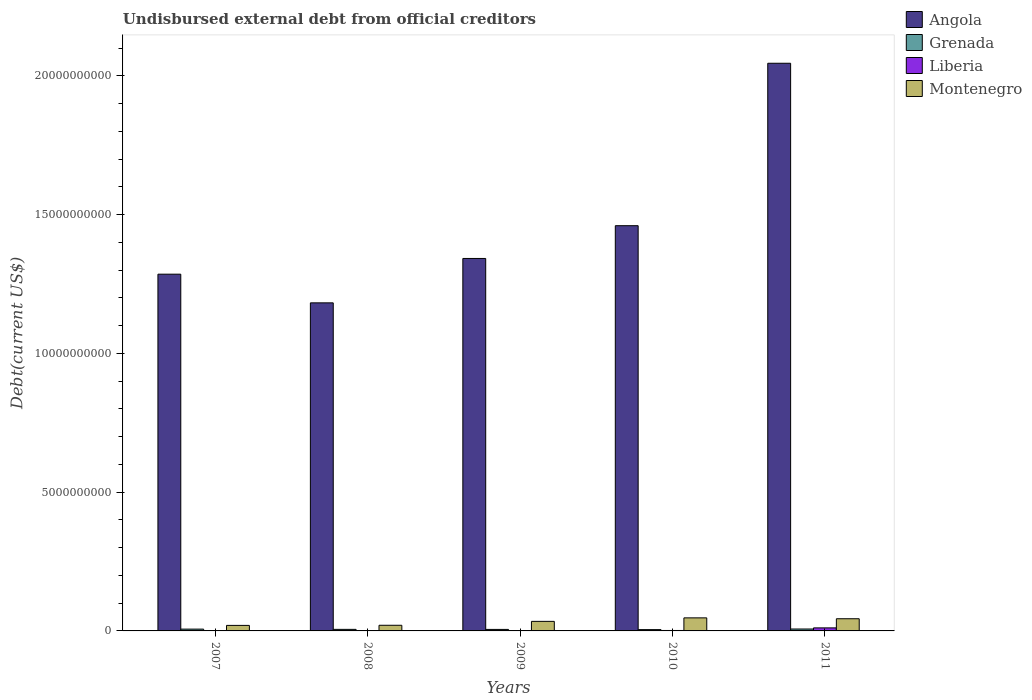How many groups of bars are there?
Make the answer very short. 5. Are the number of bars per tick equal to the number of legend labels?
Provide a succinct answer. Yes. Are the number of bars on each tick of the X-axis equal?
Keep it short and to the point. Yes. What is the label of the 2nd group of bars from the left?
Provide a short and direct response. 2008. In how many cases, is the number of bars for a given year not equal to the number of legend labels?
Give a very brief answer. 0. What is the total debt in Grenada in 2009?
Make the answer very short. 5.44e+07. Across all years, what is the maximum total debt in Angola?
Provide a succinct answer. 2.05e+1. Across all years, what is the minimum total debt in Angola?
Provide a succinct answer. 1.18e+1. In which year was the total debt in Montenegro minimum?
Your answer should be very brief. 2007. What is the total total debt in Angola in the graph?
Give a very brief answer. 7.32e+1. What is the difference between the total debt in Angola in 2007 and that in 2010?
Offer a terse response. -1.75e+09. What is the difference between the total debt in Liberia in 2011 and the total debt in Montenegro in 2008?
Offer a terse response. -9.45e+07. What is the average total debt in Montenegro per year?
Make the answer very short. 3.31e+08. In the year 2011, what is the difference between the total debt in Angola and total debt in Grenada?
Give a very brief answer. 2.04e+1. In how many years, is the total debt in Grenada greater than 2000000000 US$?
Your answer should be compact. 0. What is the ratio of the total debt in Liberia in 2010 to that in 2011?
Offer a terse response. 0.15. Is the total debt in Angola in 2007 less than that in 2010?
Give a very brief answer. Yes. Is the difference between the total debt in Angola in 2009 and 2010 greater than the difference between the total debt in Grenada in 2009 and 2010?
Keep it short and to the point. No. What is the difference between the highest and the second highest total debt in Montenegro?
Your answer should be compact. 3.17e+07. What is the difference between the highest and the lowest total debt in Grenada?
Keep it short and to the point. 2.21e+07. Is the sum of the total debt in Angola in 2007 and 2011 greater than the maximum total debt in Grenada across all years?
Offer a very short reply. Yes. What does the 2nd bar from the left in 2009 represents?
Your response must be concise. Grenada. What does the 2nd bar from the right in 2010 represents?
Give a very brief answer. Liberia. Is it the case that in every year, the sum of the total debt in Liberia and total debt in Montenegro is greater than the total debt in Angola?
Keep it short and to the point. No. Are all the bars in the graph horizontal?
Provide a short and direct response. No. How many years are there in the graph?
Provide a short and direct response. 5. What is the difference between two consecutive major ticks on the Y-axis?
Your answer should be compact. 5.00e+09. Does the graph contain any zero values?
Offer a terse response. No. Does the graph contain grids?
Ensure brevity in your answer.  No. Where does the legend appear in the graph?
Provide a succinct answer. Top right. What is the title of the graph?
Your response must be concise. Undisbursed external debt from official creditors. Does "Turks and Caicos Islands" appear as one of the legend labels in the graph?
Offer a very short reply. No. What is the label or title of the X-axis?
Your answer should be compact. Years. What is the label or title of the Y-axis?
Your answer should be compact. Debt(current US$). What is the Debt(current US$) of Angola in 2007?
Keep it short and to the point. 1.29e+1. What is the Debt(current US$) in Grenada in 2007?
Your response must be concise. 6.52e+07. What is the Debt(current US$) in Liberia in 2007?
Provide a short and direct response. 5.48e+06. What is the Debt(current US$) in Montenegro in 2007?
Offer a very short reply. 1.99e+08. What is the Debt(current US$) of Angola in 2008?
Your answer should be compact. 1.18e+1. What is the Debt(current US$) of Grenada in 2008?
Provide a succinct answer. 5.57e+07. What is the Debt(current US$) of Liberia in 2008?
Your answer should be compact. 5.85e+06. What is the Debt(current US$) in Montenegro in 2008?
Keep it short and to the point. 2.04e+08. What is the Debt(current US$) of Angola in 2009?
Provide a short and direct response. 1.34e+1. What is the Debt(current US$) in Grenada in 2009?
Offer a terse response. 5.44e+07. What is the Debt(current US$) of Liberia in 2009?
Provide a succinct answer. 5.86e+06. What is the Debt(current US$) of Montenegro in 2009?
Offer a very short reply. 3.44e+08. What is the Debt(current US$) of Angola in 2010?
Provide a succinct answer. 1.46e+1. What is the Debt(current US$) in Grenada in 2010?
Make the answer very short. 4.69e+07. What is the Debt(current US$) of Liberia in 2010?
Give a very brief answer. 1.60e+07. What is the Debt(current US$) of Montenegro in 2010?
Keep it short and to the point. 4.71e+08. What is the Debt(current US$) of Angola in 2011?
Keep it short and to the point. 2.05e+1. What is the Debt(current US$) of Grenada in 2011?
Your answer should be very brief. 6.91e+07. What is the Debt(current US$) in Liberia in 2011?
Provide a short and direct response. 1.09e+08. What is the Debt(current US$) in Montenegro in 2011?
Give a very brief answer. 4.39e+08. Across all years, what is the maximum Debt(current US$) in Angola?
Offer a terse response. 2.05e+1. Across all years, what is the maximum Debt(current US$) of Grenada?
Offer a terse response. 6.91e+07. Across all years, what is the maximum Debt(current US$) in Liberia?
Give a very brief answer. 1.09e+08. Across all years, what is the maximum Debt(current US$) of Montenegro?
Your response must be concise. 4.71e+08. Across all years, what is the minimum Debt(current US$) of Angola?
Your response must be concise. 1.18e+1. Across all years, what is the minimum Debt(current US$) in Grenada?
Your answer should be compact. 4.69e+07. Across all years, what is the minimum Debt(current US$) in Liberia?
Keep it short and to the point. 5.48e+06. Across all years, what is the minimum Debt(current US$) in Montenegro?
Provide a succinct answer. 1.99e+08. What is the total Debt(current US$) in Angola in the graph?
Your answer should be compact. 7.32e+1. What is the total Debt(current US$) in Grenada in the graph?
Keep it short and to the point. 2.91e+08. What is the total Debt(current US$) in Liberia in the graph?
Keep it short and to the point. 1.42e+08. What is the total Debt(current US$) of Montenegro in the graph?
Give a very brief answer. 1.66e+09. What is the difference between the Debt(current US$) in Angola in 2007 and that in 2008?
Your answer should be very brief. 1.03e+09. What is the difference between the Debt(current US$) in Grenada in 2007 and that in 2008?
Your response must be concise. 9.50e+06. What is the difference between the Debt(current US$) of Liberia in 2007 and that in 2008?
Provide a succinct answer. -3.77e+05. What is the difference between the Debt(current US$) of Montenegro in 2007 and that in 2008?
Offer a very short reply. -4.64e+06. What is the difference between the Debt(current US$) of Angola in 2007 and that in 2009?
Provide a succinct answer. -5.66e+08. What is the difference between the Debt(current US$) in Grenada in 2007 and that in 2009?
Make the answer very short. 1.08e+07. What is the difference between the Debt(current US$) of Liberia in 2007 and that in 2009?
Offer a very short reply. -3.82e+05. What is the difference between the Debt(current US$) of Montenegro in 2007 and that in 2009?
Ensure brevity in your answer.  -1.45e+08. What is the difference between the Debt(current US$) of Angola in 2007 and that in 2010?
Your answer should be very brief. -1.75e+09. What is the difference between the Debt(current US$) in Grenada in 2007 and that in 2010?
Ensure brevity in your answer.  1.83e+07. What is the difference between the Debt(current US$) of Liberia in 2007 and that in 2010?
Make the answer very short. -1.06e+07. What is the difference between the Debt(current US$) of Montenegro in 2007 and that in 2010?
Offer a very short reply. -2.72e+08. What is the difference between the Debt(current US$) of Angola in 2007 and that in 2011?
Provide a short and direct response. -7.60e+09. What is the difference between the Debt(current US$) in Grenada in 2007 and that in 2011?
Provide a short and direct response. -3.84e+06. What is the difference between the Debt(current US$) of Liberia in 2007 and that in 2011?
Keep it short and to the point. -1.04e+08. What is the difference between the Debt(current US$) in Montenegro in 2007 and that in 2011?
Offer a very short reply. -2.40e+08. What is the difference between the Debt(current US$) in Angola in 2008 and that in 2009?
Provide a succinct answer. -1.60e+09. What is the difference between the Debt(current US$) of Grenada in 2008 and that in 2009?
Your response must be concise. 1.34e+06. What is the difference between the Debt(current US$) of Liberia in 2008 and that in 2009?
Make the answer very short. -5000. What is the difference between the Debt(current US$) of Montenegro in 2008 and that in 2009?
Offer a very short reply. -1.40e+08. What is the difference between the Debt(current US$) of Angola in 2008 and that in 2010?
Provide a succinct answer. -2.78e+09. What is the difference between the Debt(current US$) in Grenada in 2008 and that in 2010?
Offer a very short reply. 8.79e+06. What is the difference between the Debt(current US$) in Liberia in 2008 and that in 2010?
Keep it short and to the point. -1.02e+07. What is the difference between the Debt(current US$) in Montenegro in 2008 and that in 2010?
Provide a succinct answer. -2.67e+08. What is the difference between the Debt(current US$) in Angola in 2008 and that in 2011?
Give a very brief answer. -8.63e+09. What is the difference between the Debt(current US$) in Grenada in 2008 and that in 2011?
Ensure brevity in your answer.  -1.33e+07. What is the difference between the Debt(current US$) in Liberia in 2008 and that in 2011?
Ensure brevity in your answer.  -1.03e+08. What is the difference between the Debt(current US$) in Montenegro in 2008 and that in 2011?
Make the answer very short. -2.35e+08. What is the difference between the Debt(current US$) of Angola in 2009 and that in 2010?
Give a very brief answer. -1.18e+09. What is the difference between the Debt(current US$) of Grenada in 2009 and that in 2010?
Ensure brevity in your answer.  7.44e+06. What is the difference between the Debt(current US$) in Liberia in 2009 and that in 2010?
Your answer should be very brief. -1.02e+07. What is the difference between the Debt(current US$) in Montenegro in 2009 and that in 2010?
Keep it short and to the point. -1.27e+08. What is the difference between the Debt(current US$) in Angola in 2009 and that in 2011?
Your answer should be compact. -7.03e+09. What is the difference between the Debt(current US$) in Grenada in 2009 and that in 2011?
Ensure brevity in your answer.  -1.47e+07. What is the difference between the Debt(current US$) of Liberia in 2009 and that in 2011?
Make the answer very short. -1.03e+08. What is the difference between the Debt(current US$) of Montenegro in 2009 and that in 2011?
Provide a succinct answer. -9.49e+07. What is the difference between the Debt(current US$) in Angola in 2010 and that in 2011?
Make the answer very short. -5.85e+09. What is the difference between the Debt(current US$) in Grenada in 2010 and that in 2011?
Your response must be concise. -2.21e+07. What is the difference between the Debt(current US$) of Liberia in 2010 and that in 2011?
Make the answer very short. -9.32e+07. What is the difference between the Debt(current US$) in Montenegro in 2010 and that in 2011?
Keep it short and to the point. 3.17e+07. What is the difference between the Debt(current US$) of Angola in 2007 and the Debt(current US$) of Grenada in 2008?
Your answer should be very brief. 1.28e+1. What is the difference between the Debt(current US$) in Angola in 2007 and the Debt(current US$) in Liberia in 2008?
Offer a very short reply. 1.29e+1. What is the difference between the Debt(current US$) of Angola in 2007 and the Debt(current US$) of Montenegro in 2008?
Provide a short and direct response. 1.27e+1. What is the difference between the Debt(current US$) of Grenada in 2007 and the Debt(current US$) of Liberia in 2008?
Offer a terse response. 5.94e+07. What is the difference between the Debt(current US$) of Grenada in 2007 and the Debt(current US$) of Montenegro in 2008?
Your answer should be very brief. -1.38e+08. What is the difference between the Debt(current US$) in Liberia in 2007 and the Debt(current US$) in Montenegro in 2008?
Make the answer very short. -1.98e+08. What is the difference between the Debt(current US$) of Angola in 2007 and the Debt(current US$) of Grenada in 2009?
Make the answer very short. 1.28e+1. What is the difference between the Debt(current US$) in Angola in 2007 and the Debt(current US$) in Liberia in 2009?
Provide a short and direct response. 1.29e+1. What is the difference between the Debt(current US$) of Angola in 2007 and the Debt(current US$) of Montenegro in 2009?
Give a very brief answer. 1.25e+1. What is the difference between the Debt(current US$) of Grenada in 2007 and the Debt(current US$) of Liberia in 2009?
Offer a very short reply. 5.94e+07. What is the difference between the Debt(current US$) of Grenada in 2007 and the Debt(current US$) of Montenegro in 2009?
Your answer should be compact. -2.79e+08. What is the difference between the Debt(current US$) of Liberia in 2007 and the Debt(current US$) of Montenegro in 2009?
Offer a very short reply. -3.39e+08. What is the difference between the Debt(current US$) of Angola in 2007 and the Debt(current US$) of Grenada in 2010?
Offer a very short reply. 1.28e+1. What is the difference between the Debt(current US$) in Angola in 2007 and the Debt(current US$) in Liberia in 2010?
Ensure brevity in your answer.  1.28e+1. What is the difference between the Debt(current US$) in Angola in 2007 and the Debt(current US$) in Montenegro in 2010?
Give a very brief answer. 1.24e+1. What is the difference between the Debt(current US$) of Grenada in 2007 and the Debt(current US$) of Liberia in 2010?
Your response must be concise. 4.92e+07. What is the difference between the Debt(current US$) of Grenada in 2007 and the Debt(current US$) of Montenegro in 2010?
Give a very brief answer. -4.05e+08. What is the difference between the Debt(current US$) in Liberia in 2007 and the Debt(current US$) in Montenegro in 2010?
Offer a very short reply. -4.65e+08. What is the difference between the Debt(current US$) in Angola in 2007 and the Debt(current US$) in Grenada in 2011?
Offer a very short reply. 1.28e+1. What is the difference between the Debt(current US$) of Angola in 2007 and the Debt(current US$) of Liberia in 2011?
Ensure brevity in your answer.  1.27e+1. What is the difference between the Debt(current US$) in Angola in 2007 and the Debt(current US$) in Montenegro in 2011?
Your answer should be compact. 1.24e+1. What is the difference between the Debt(current US$) of Grenada in 2007 and the Debt(current US$) of Liberia in 2011?
Offer a terse response. -4.40e+07. What is the difference between the Debt(current US$) of Grenada in 2007 and the Debt(current US$) of Montenegro in 2011?
Make the answer very short. -3.74e+08. What is the difference between the Debt(current US$) of Liberia in 2007 and the Debt(current US$) of Montenegro in 2011?
Give a very brief answer. -4.33e+08. What is the difference between the Debt(current US$) of Angola in 2008 and the Debt(current US$) of Grenada in 2009?
Make the answer very short. 1.18e+1. What is the difference between the Debt(current US$) of Angola in 2008 and the Debt(current US$) of Liberia in 2009?
Offer a terse response. 1.18e+1. What is the difference between the Debt(current US$) in Angola in 2008 and the Debt(current US$) in Montenegro in 2009?
Offer a terse response. 1.15e+1. What is the difference between the Debt(current US$) of Grenada in 2008 and the Debt(current US$) of Liberia in 2009?
Your answer should be very brief. 4.99e+07. What is the difference between the Debt(current US$) of Grenada in 2008 and the Debt(current US$) of Montenegro in 2009?
Your answer should be compact. -2.88e+08. What is the difference between the Debt(current US$) of Liberia in 2008 and the Debt(current US$) of Montenegro in 2009?
Offer a terse response. -3.38e+08. What is the difference between the Debt(current US$) of Angola in 2008 and the Debt(current US$) of Grenada in 2010?
Ensure brevity in your answer.  1.18e+1. What is the difference between the Debt(current US$) in Angola in 2008 and the Debt(current US$) in Liberia in 2010?
Keep it short and to the point. 1.18e+1. What is the difference between the Debt(current US$) of Angola in 2008 and the Debt(current US$) of Montenegro in 2010?
Your answer should be very brief. 1.14e+1. What is the difference between the Debt(current US$) of Grenada in 2008 and the Debt(current US$) of Liberia in 2010?
Give a very brief answer. 3.97e+07. What is the difference between the Debt(current US$) in Grenada in 2008 and the Debt(current US$) in Montenegro in 2010?
Provide a short and direct response. -4.15e+08. What is the difference between the Debt(current US$) of Liberia in 2008 and the Debt(current US$) of Montenegro in 2010?
Provide a succinct answer. -4.65e+08. What is the difference between the Debt(current US$) in Angola in 2008 and the Debt(current US$) in Grenada in 2011?
Ensure brevity in your answer.  1.18e+1. What is the difference between the Debt(current US$) in Angola in 2008 and the Debt(current US$) in Liberia in 2011?
Your answer should be compact. 1.17e+1. What is the difference between the Debt(current US$) of Angola in 2008 and the Debt(current US$) of Montenegro in 2011?
Give a very brief answer. 1.14e+1. What is the difference between the Debt(current US$) in Grenada in 2008 and the Debt(current US$) in Liberia in 2011?
Provide a succinct answer. -5.35e+07. What is the difference between the Debt(current US$) in Grenada in 2008 and the Debt(current US$) in Montenegro in 2011?
Your answer should be very brief. -3.83e+08. What is the difference between the Debt(current US$) in Liberia in 2008 and the Debt(current US$) in Montenegro in 2011?
Offer a very short reply. -4.33e+08. What is the difference between the Debt(current US$) of Angola in 2009 and the Debt(current US$) of Grenada in 2010?
Offer a terse response. 1.34e+1. What is the difference between the Debt(current US$) in Angola in 2009 and the Debt(current US$) in Liberia in 2010?
Provide a short and direct response. 1.34e+1. What is the difference between the Debt(current US$) in Angola in 2009 and the Debt(current US$) in Montenegro in 2010?
Your answer should be very brief. 1.30e+1. What is the difference between the Debt(current US$) of Grenada in 2009 and the Debt(current US$) of Liberia in 2010?
Your answer should be very brief. 3.83e+07. What is the difference between the Debt(current US$) in Grenada in 2009 and the Debt(current US$) in Montenegro in 2010?
Offer a very short reply. -4.16e+08. What is the difference between the Debt(current US$) of Liberia in 2009 and the Debt(current US$) of Montenegro in 2010?
Provide a short and direct response. -4.65e+08. What is the difference between the Debt(current US$) of Angola in 2009 and the Debt(current US$) of Grenada in 2011?
Offer a very short reply. 1.34e+1. What is the difference between the Debt(current US$) in Angola in 2009 and the Debt(current US$) in Liberia in 2011?
Make the answer very short. 1.33e+1. What is the difference between the Debt(current US$) of Angola in 2009 and the Debt(current US$) of Montenegro in 2011?
Keep it short and to the point. 1.30e+1. What is the difference between the Debt(current US$) of Grenada in 2009 and the Debt(current US$) of Liberia in 2011?
Make the answer very short. -5.49e+07. What is the difference between the Debt(current US$) in Grenada in 2009 and the Debt(current US$) in Montenegro in 2011?
Your answer should be compact. -3.85e+08. What is the difference between the Debt(current US$) of Liberia in 2009 and the Debt(current US$) of Montenegro in 2011?
Keep it short and to the point. -4.33e+08. What is the difference between the Debt(current US$) in Angola in 2010 and the Debt(current US$) in Grenada in 2011?
Your answer should be compact. 1.45e+1. What is the difference between the Debt(current US$) of Angola in 2010 and the Debt(current US$) of Liberia in 2011?
Offer a very short reply. 1.45e+1. What is the difference between the Debt(current US$) of Angola in 2010 and the Debt(current US$) of Montenegro in 2011?
Keep it short and to the point. 1.42e+1. What is the difference between the Debt(current US$) of Grenada in 2010 and the Debt(current US$) of Liberia in 2011?
Give a very brief answer. -6.23e+07. What is the difference between the Debt(current US$) in Grenada in 2010 and the Debt(current US$) in Montenegro in 2011?
Your response must be concise. -3.92e+08. What is the difference between the Debt(current US$) in Liberia in 2010 and the Debt(current US$) in Montenegro in 2011?
Offer a very short reply. -4.23e+08. What is the average Debt(current US$) of Angola per year?
Offer a very short reply. 1.46e+1. What is the average Debt(current US$) of Grenada per year?
Provide a short and direct response. 5.83e+07. What is the average Debt(current US$) of Liberia per year?
Your answer should be very brief. 2.85e+07. What is the average Debt(current US$) of Montenegro per year?
Provide a succinct answer. 3.31e+08. In the year 2007, what is the difference between the Debt(current US$) in Angola and Debt(current US$) in Grenada?
Make the answer very short. 1.28e+1. In the year 2007, what is the difference between the Debt(current US$) of Angola and Debt(current US$) of Liberia?
Give a very brief answer. 1.29e+1. In the year 2007, what is the difference between the Debt(current US$) of Angola and Debt(current US$) of Montenegro?
Provide a short and direct response. 1.27e+1. In the year 2007, what is the difference between the Debt(current US$) in Grenada and Debt(current US$) in Liberia?
Provide a succinct answer. 5.98e+07. In the year 2007, what is the difference between the Debt(current US$) in Grenada and Debt(current US$) in Montenegro?
Your answer should be very brief. -1.34e+08. In the year 2007, what is the difference between the Debt(current US$) of Liberia and Debt(current US$) of Montenegro?
Provide a short and direct response. -1.94e+08. In the year 2008, what is the difference between the Debt(current US$) of Angola and Debt(current US$) of Grenada?
Provide a short and direct response. 1.18e+1. In the year 2008, what is the difference between the Debt(current US$) in Angola and Debt(current US$) in Liberia?
Provide a succinct answer. 1.18e+1. In the year 2008, what is the difference between the Debt(current US$) in Angola and Debt(current US$) in Montenegro?
Offer a very short reply. 1.16e+1. In the year 2008, what is the difference between the Debt(current US$) of Grenada and Debt(current US$) of Liberia?
Give a very brief answer. 4.99e+07. In the year 2008, what is the difference between the Debt(current US$) of Grenada and Debt(current US$) of Montenegro?
Give a very brief answer. -1.48e+08. In the year 2008, what is the difference between the Debt(current US$) in Liberia and Debt(current US$) in Montenegro?
Offer a very short reply. -1.98e+08. In the year 2009, what is the difference between the Debt(current US$) in Angola and Debt(current US$) in Grenada?
Offer a very short reply. 1.34e+1. In the year 2009, what is the difference between the Debt(current US$) in Angola and Debt(current US$) in Liberia?
Your answer should be very brief. 1.34e+1. In the year 2009, what is the difference between the Debt(current US$) in Angola and Debt(current US$) in Montenegro?
Provide a short and direct response. 1.31e+1. In the year 2009, what is the difference between the Debt(current US$) in Grenada and Debt(current US$) in Liberia?
Your response must be concise. 4.85e+07. In the year 2009, what is the difference between the Debt(current US$) of Grenada and Debt(current US$) of Montenegro?
Make the answer very short. -2.90e+08. In the year 2009, what is the difference between the Debt(current US$) in Liberia and Debt(current US$) in Montenegro?
Make the answer very short. -3.38e+08. In the year 2010, what is the difference between the Debt(current US$) of Angola and Debt(current US$) of Grenada?
Your answer should be very brief. 1.46e+1. In the year 2010, what is the difference between the Debt(current US$) of Angola and Debt(current US$) of Liberia?
Make the answer very short. 1.46e+1. In the year 2010, what is the difference between the Debt(current US$) in Angola and Debt(current US$) in Montenegro?
Make the answer very short. 1.41e+1. In the year 2010, what is the difference between the Debt(current US$) of Grenada and Debt(current US$) of Liberia?
Offer a very short reply. 3.09e+07. In the year 2010, what is the difference between the Debt(current US$) in Grenada and Debt(current US$) in Montenegro?
Ensure brevity in your answer.  -4.24e+08. In the year 2010, what is the difference between the Debt(current US$) in Liberia and Debt(current US$) in Montenegro?
Your answer should be very brief. -4.55e+08. In the year 2011, what is the difference between the Debt(current US$) in Angola and Debt(current US$) in Grenada?
Offer a terse response. 2.04e+1. In the year 2011, what is the difference between the Debt(current US$) in Angola and Debt(current US$) in Liberia?
Ensure brevity in your answer.  2.03e+1. In the year 2011, what is the difference between the Debt(current US$) in Angola and Debt(current US$) in Montenegro?
Keep it short and to the point. 2.00e+1. In the year 2011, what is the difference between the Debt(current US$) in Grenada and Debt(current US$) in Liberia?
Offer a very short reply. -4.02e+07. In the year 2011, what is the difference between the Debt(current US$) in Grenada and Debt(current US$) in Montenegro?
Offer a terse response. -3.70e+08. In the year 2011, what is the difference between the Debt(current US$) of Liberia and Debt(current US$) of Montenegro?
Your answer should be compact. -3.30e+08. What is the ratio of the Debt(current US$) of Angola in 2007 to that in 2008?
Keep it short and to the point. 1.09. What is the ratio of the Debt(current US$) in Grenada in 2007 to that in 2008?
Your answer should be very brief. 1.17. What is the ratio of the Debt(current US$) in Liberia in 2007 to that in 2008?
Offer a terse response. 0.94. What is the ratio of the Debt(current US$) in Montenegro in 2007 to that in 2008?
Keep it short and to the point. 0.98. What is the ratio of the Debt(current US$) in Angola in 2007 to that in 2009?
Offer a very short reply. 0.96. What is the ratio of the Debt(current US$) of Grenada in 2007 to that in 2009?
Ensure brevity in your answer.  1.2. What is the ratio of the Debt(current US$) in Liberia in 2007 to that in 2009?
Offer a very short reply. 0.93. What is the ratio of the Debt(current US$) of Montenegro in 2007 to that in 2009?
Give a very brief answer. 0.58. What is the ratio of the Debt(current US$) of Angola in 2007 to that in 2010?
Your answer should be compact. 0.88. What is the ratio of the Debt(current US$) of Grenada in 2007 to that in 2010?
Ensure brevity in your answer.  1.39. What is the ratio of the Debt(current US$) in Liberia in 2007 to that in 2010?
Give a very brief answer. 0.34. What is the ratio of the Debt(current US$) of Montenegro in 2007 to that in 2010?
Give a very brief answer. 0.42. What is the ratio of the Debt(current US$) in Angola in 2007 to that in 2011?
Provide a succinct answer. 0.63. What is the ratio of the Debt(current US$) in Liberia in 2007 to that in 2011?
Offer a terse response. 0.05. What is the ratio of the Debt(current US$) in Montenegro in 2007 to that in 2011?
Give a very brief answer. 0.45. What is the ratio of the Debt(current US$) of Angola in 2008 to that in 2009?
Provide a short and direct response. 0.88. What is the ratio of the Debt(current US$) in Grenada in 2008 to that in 2009?
Keep it short and to the point. 1.02. What is the ratio of the Debt(current US$) in Montenegro in 2008 to that in 2009?
Provide a short and direct response. 0.59. What is the ratio of the Debt(current US$) in Angola in 2008 to that in 2010?
Offer a terse response. 0.81. What is the ratio of the Debt(current US$) of Grenada in 2008 to that in 2010?
Provide a short and direct response. 1.19. What is the ratio of the Debt(current US$) in Liberia in 2008 to that in 2010?
Keep it short and to the point. 0.36. What is the ratio of the Debt(current US$) in Montenegro in 2008 to that in 2010?
Offer a very short reply. 0.43. What is the ratio of the Debt(current US$) of Angola in 2008 to that in 2011?
Keep it short and to the point. 0.58. What is the ratio of the Debt(current US$) of Grenada in 2008 to that in 2011?
Keep it short and to the point. 0.81. What is the ratio of the Debt(current US$) in Liberia in 2008 to that in 2011?
Offer a very short reply. 0.05. What is the ratio of the Debt(current US$) of Montenegro in 2008 to that in 2011?
Provide a short and direct response. 0.46. What is the ratio of the Debt(current US$) of Angola in 2009 to that in 2010?
Offer a very short reply. 0.92. What is the ratio of the Debt(current US$) of Grenada in 2009 to that in 2010?
Offer a terse response. 1.16. What is the ratio of the Debt(current US$) of Liberia in 2009 to that in 2010?
Keep it short and to the point. 0.36. What is the ratio of the Debt(current US$) in Montenegro in 2009 to that in 2010?
Give a very brief answer. 0.73. What is the ratio of the Debt(current US$) of Angola in 2009 to that in 2011?
Offer a terse response. 0.66. What is the ratio of the Debt(current US$) in Grenada in 2009 to that in 2011?
Give a very brief answer. 0.79. What is the ratio of the Debt(current US$) of Liberia in 2009 to that in 2011?
Keep it short and to the point. 0.05. What is the ratio of the Debt(current US$) of Montenegro in 2009 to that in 2011?
Ensure brevity in your answer.  0.78. What is the ratio of the Debt(current US$) of Angola in 2010 to that in 2011?
Offer a terse response. 0.71. What is the ratio of the Debt(current US$) of Grenada in 2010 to that in 2011?
Give a very brief answer. 0.68. What is the ratio of the Debt(current US$) of Liberia in 2010 to that in 2011?
Offer a terse response. 0.15. What is the ratio of the Debt(current US$) of Montenegro in 2010 to that in 2011?
Your answer should be compact. 1.07. What is the difference between the highest and the second highest Debt(current US$) of Angola?
Ensure brevity in your answer.  5.85e+09. What is the difference between the highest and the second highest Debt(current US$) of Grenada?
Provide a short and direct response. 3.84e+06. What is the difference between the highest and the second highest Debt(current US$) of Liberia?
Keep it short and to the point. 9.32e+07. What is the difference between the highest and the second highest Debt(current US$) in Montenegro?
Offer a very short reply. 3.17e+07. What is the difference between the highest and the lowest Debt(current US$) in Angola?
Offer a very short reply. 8.63e+09. What is the difference between the highest and the lowest Debt(current US$) in Grenada?
Give a very brief answer. 2.21e+07. What is the difference between the highest and the lowest Debt(current US$) of Liberia?
Offer a terse response. 1.04e+08. What is the difference between the highest and the lowest Debt(current US$) of Montenegro?
Provide a short and direct response. 2.72e+08. 